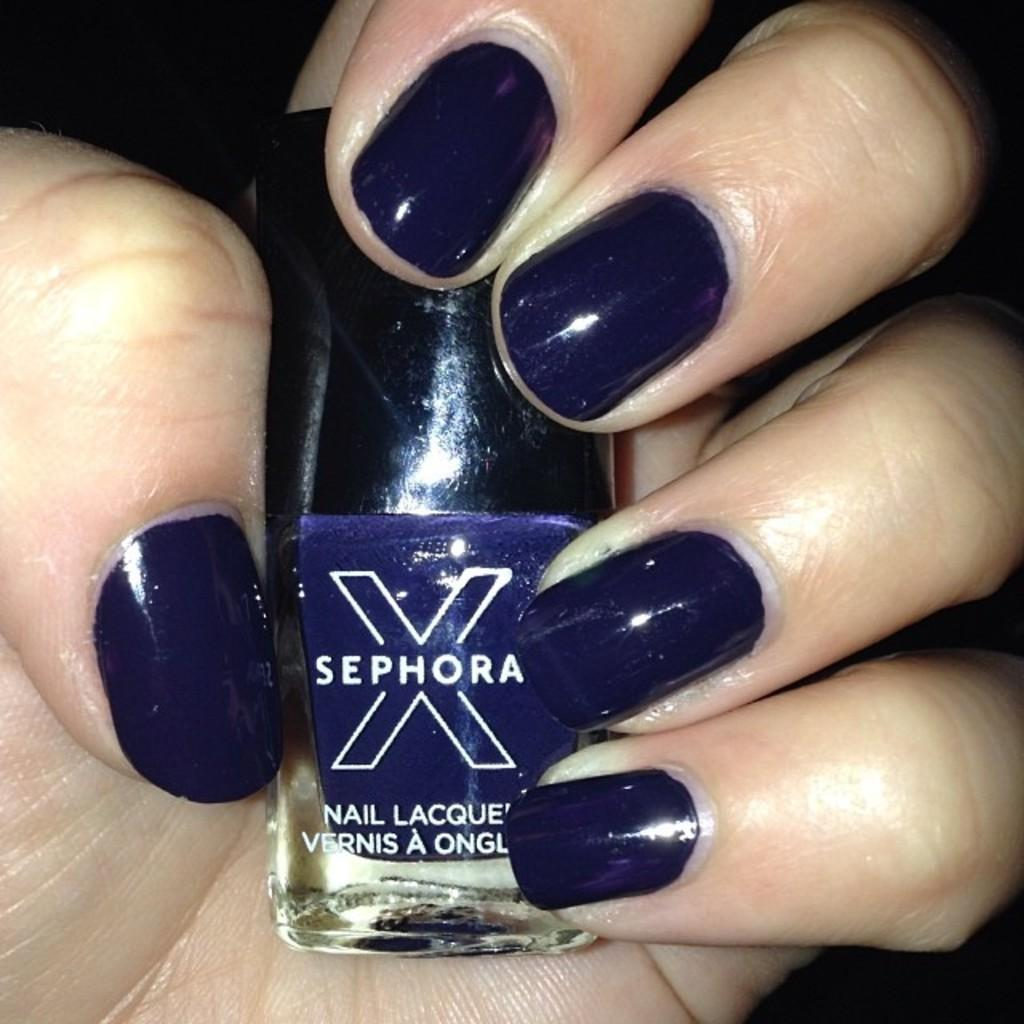What is the main subject of the image? The main subject of the image is a human hand. What is the hand holding in the image? The hand is holding blue nail polish. Can you describe the appearance of the hand in the image? The hand has nail polish on the fingers. What type of throne is the hand resting on in the image? There is no throne present in the image; it features a human hand holding blue nail polish. Can you tell me what time it is according to the watch on the hand in the image? There is no watch present on the hand in the image. 